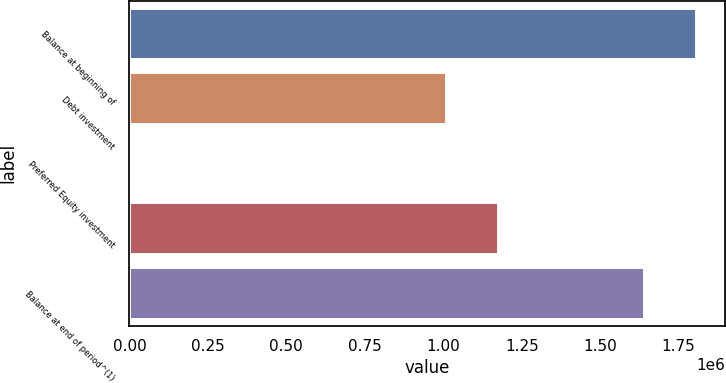<chart> <loc_0><loc_0><loc_500><loc_500><bar_chart><fcel>Balance at beginning of<fcel>Debt investment<fcel>Preferred Equity investment<fcel>Unnamed: 3<fcel>Balance at end of period^(1)<nl><fcel>1.80684e+06<fcel>1.00918e+06<fcel>5698<fcel>1.17561e+06<fcel>1.64041e+06<nl></chart> 